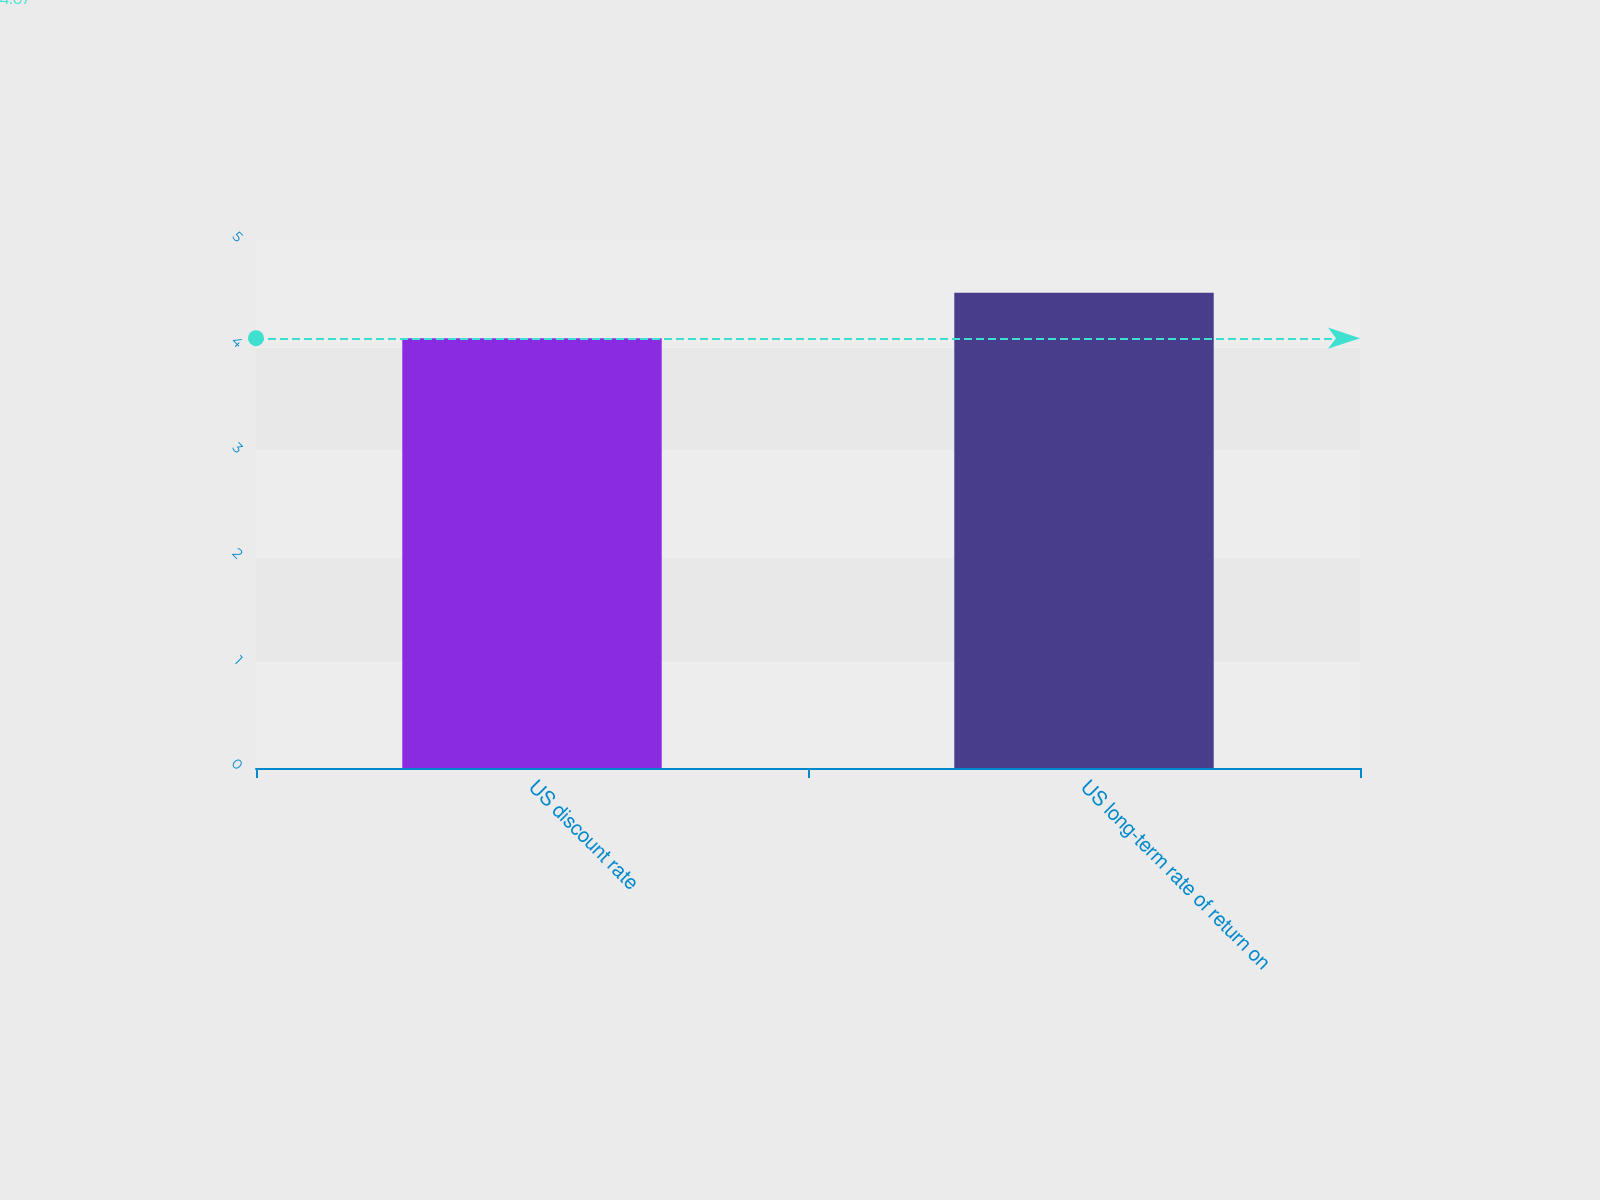Convert chart. <chart><loc_0><loc_0><loc_500><loc_500><bar_chart><fcel>US discount rate<fcel>US long-term rate of return on<nl><fcel>4.07<fcel>4.5<nl></chart> 